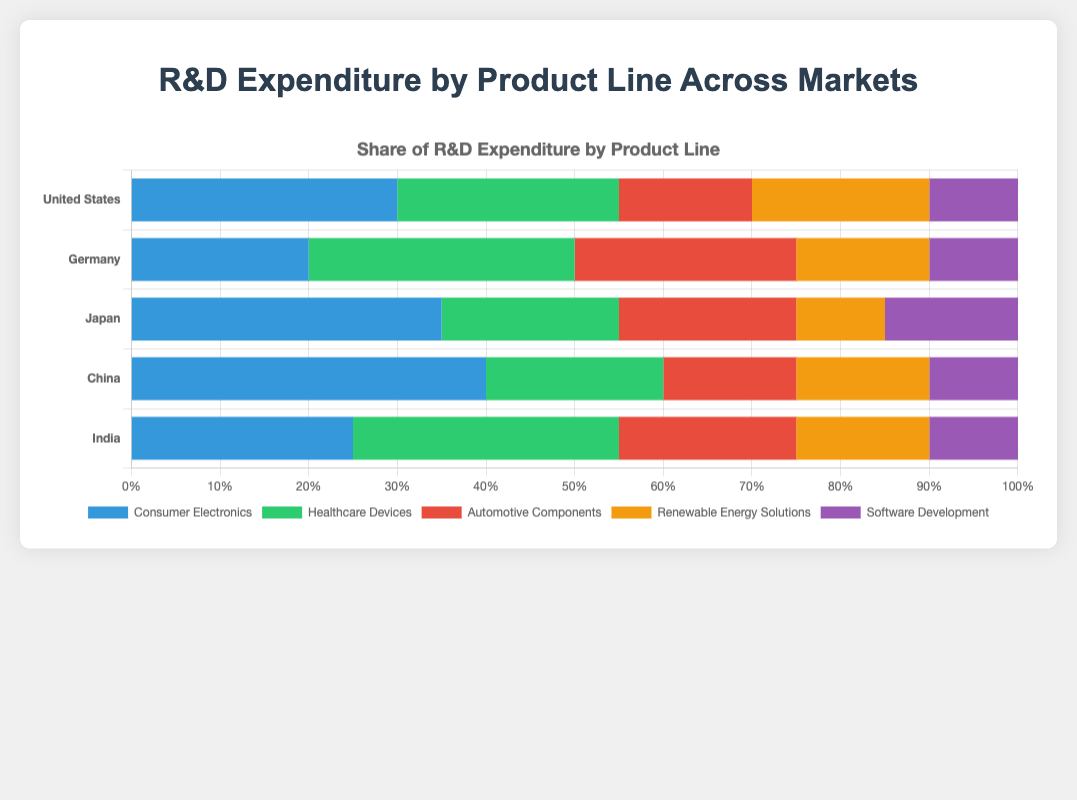Which country spends the most on Consumer Electronics R&D? To find the answer, identify the country with the longest bar for Consumer Electronics, which is shown in the blue color. China has the longest blue bar.
Answer: China What is the combined R&D expenditure percentage for Healthcare Devices and Software Development in Germany? Check the individual expenditures for Healthcare Devices and Software Development in Germany. The expenditure percentages are 30% and 10%, respectively. Adding these gives 30% + 10% = 40%.
Answer: 40% How does the R&D expenditure for Renewable Energy Solutions in India compare to that in Japan? Look at the length of the bar for Renewable Energy Solutions for both countries, colored in orange. Both India and Japan have the same length bar. The expenditure is 15% for both.
Answer: Equal What is the percentage difference in Consumer Electronics R&D expenditure between the United States and Germany? The expenditure percentages for Consumer Electronics are 30% for the United States and 20% for Germany. The difference is 30% - 20% = 10%.
Answer: 10% Which product line has the second highest R&D expenditure in Japan? Look at the stacked bars for Japan. Identify the second largest segment after Consumer Electronics (35%). Healthcare Devices have the next largest segment at 20%.
Answer: Healthcare Devices Does any country spend exactly the same percentage on Automotive Components and Renewable Energy Solutions? Check all countries for equal lengths in the segments for Automotive Components and Renewable Energy Solutions. China spends 15% on both.
Answer: China What is the average R&D expenditure percentage for Software Development across all countries? Add the expenditure percentages for Software Development in all countries: 10% (US) + 10% (Germany) + 15% (Japan) + 10% (China) + 10% (India) = 55%. Then, divide by the number of countries, which is 5. The average is 55% / 5 = 11%.
Answer: 11% Which country dedicates the smallest share of its R&D expenditure to Renewable Energy Solutions? Look for the shortest orange bar for Renewable Energy Solutions across all countries. Japan has the shortest orange bar at 10%.
Answer: Japan 